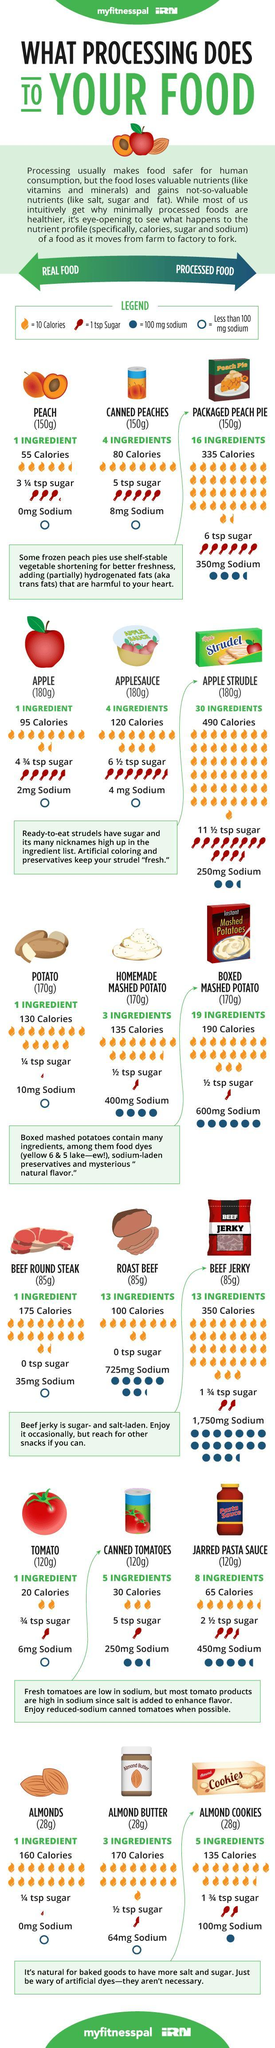Applesauce has how many calories?
Answer the question with a short phrase. 120 Canned peaches have how many calories? 80 How many ingredients in almond butter? 3 How many ingredients in canned tomatoes? 5 How many ingredients in roast beef? 13 